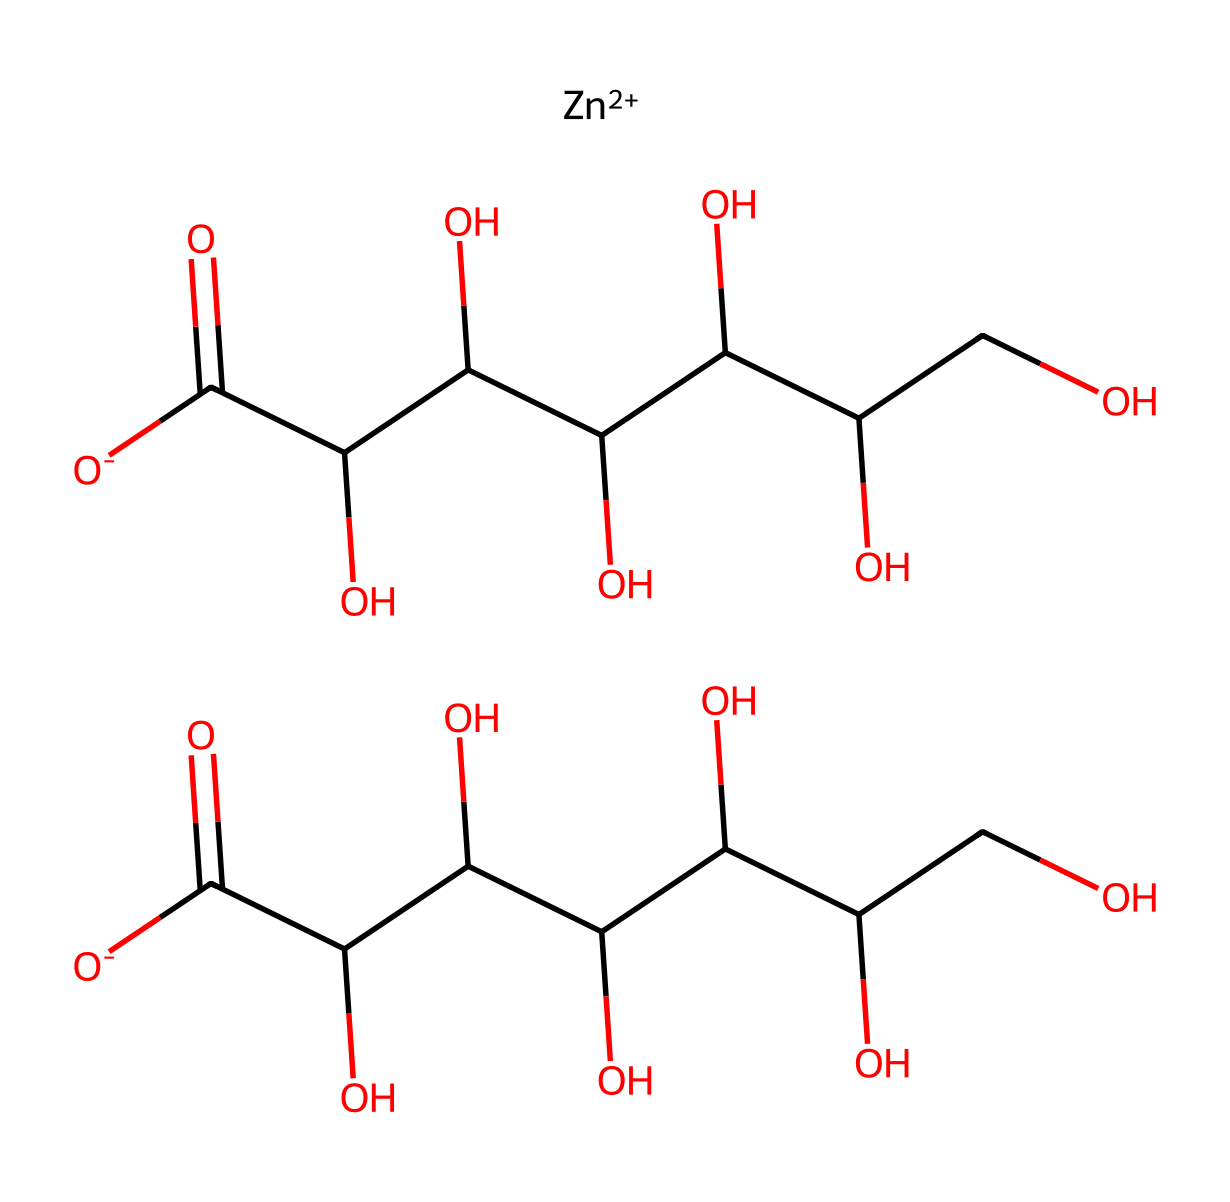What metal is present in this compound? The chemical structure includes a zinc ion indicated by [Zn++], which is a common metal used in many dietary supplements.
Answer: zinc How many carboxylic acid groups are in this structure? By analyzing the SMILES representation, it can be seen that there are a total of two carboxylic acid groups present, indicated by the [O-]C(=O) sections in the structure.
Answer: 2 What is the total number of oxygen atoms in this compound? Counting the oxygen atoms in both carboxylic acid groups and the sugar-like part of the molecule indicates that there are a total of 12 oxygen atoms present.
Answer: 12 Which class of compounds does zinc gluconate belong to? Since the compound contains a metal complex with gluconic acid and zinc, it fits within the category of organometallic compounds.
Answer: organometallic What type of bonding is primarily found in zinc gluconate? The bonding present in this structure involves coordination bonds between the zinc ion and the oxygen from the carboxylate groups, which characterizes the compound as having ionic and coordinate bonding.
Answer: coordinate How many carbon atoms are present in the structure of zinc gluconate? By observing the carbon components in the SMILES representation, there are 12 carbon atoms that can be counted from the gluconate part of the molecule.
Answer: 12 